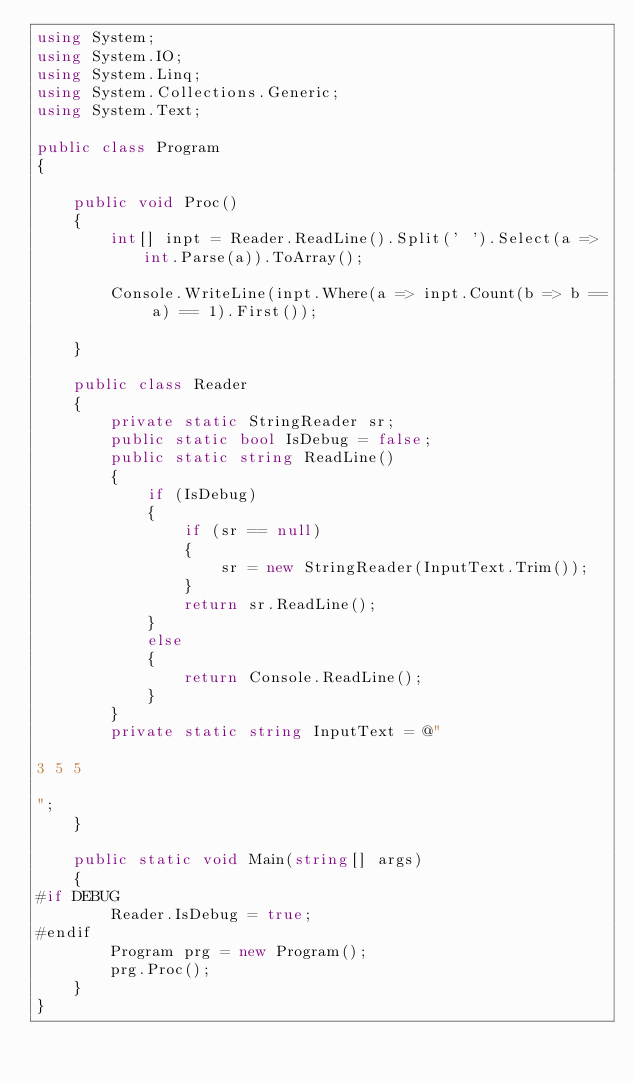<code> <loc_0><loc_0><loc_500><loc_500><_C#_>using System;
using System.IO;
using System.Linq;
using System.Collections.Generic;
using System.Text;

public class Program
{

	public void Proc()
	{
        int[] inpt = Reader.ReadLine().Split(' ').Select(a => int.Parse(a)).ToArray();

        Console.WriteLine(inpt.Where(a => inpt.Count(b => b == a) == 1).First());
    
    }

    public class Reader
	{
		private static StringReader sr;
		public static bool IsDebug = false;
		public static string ReadLine()
		{
			if (IsDebug)
			{
				if (sr == null)
				{
					sr = new StringReader(InputText.Trim());
				}
				return sr.ReadLine();
			}
			else
			{
				return Console.ReadLine();
			}
		}
		private static string InputText = @"

3 5 5

";
	}

	public static void Main(string[] args)
	{
#if DEBUG
		Reader.IsDebug = true;
#endif
		Program prg = new Program();
		prg.Proc();
	}
}
</code> 